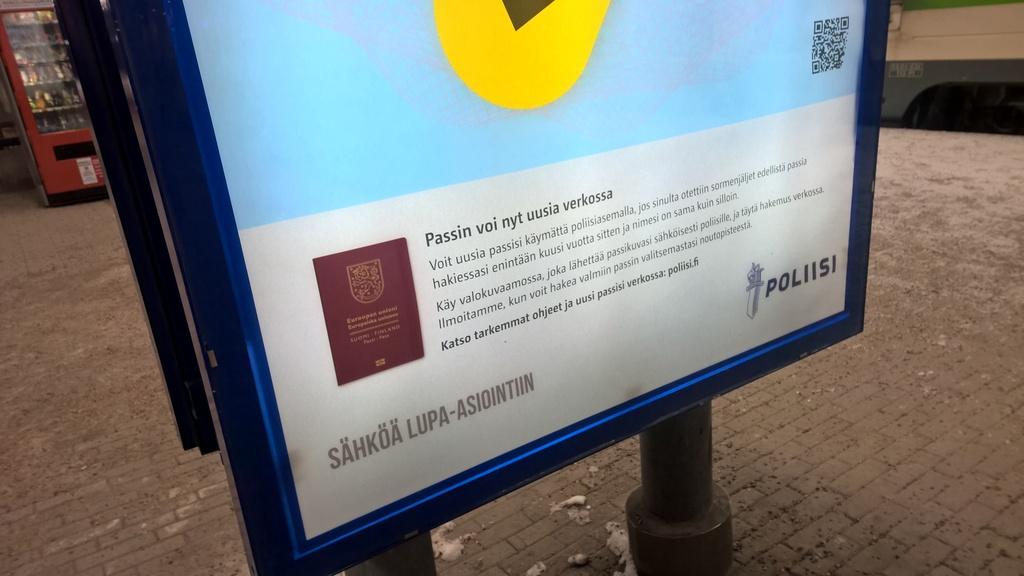What is written in the lower right hand  of the sign?
Give a very brief answer. Poliisi. What is the first word on the poster?
Make the answer very short. Passin. 